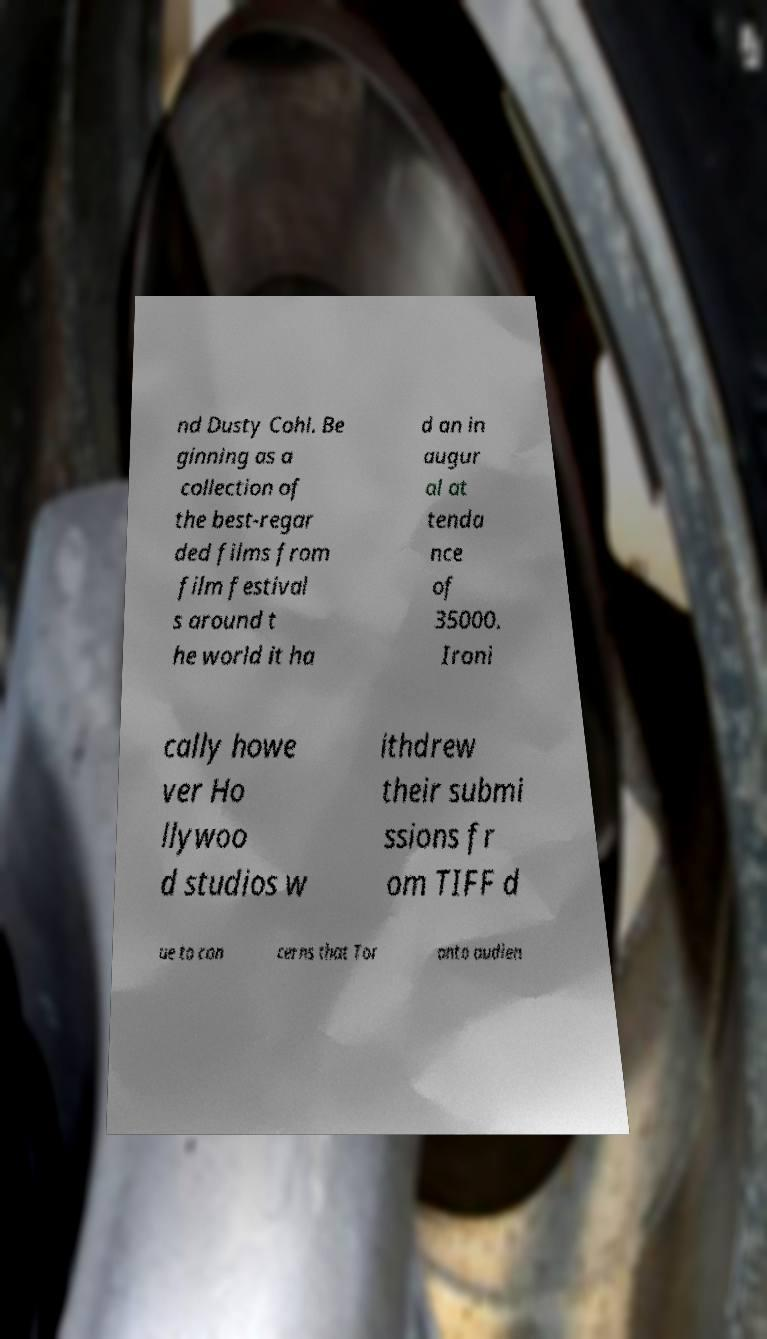There's text embedded in this image that I need extracted. Can you transcribe it verbatim? nd Dusty Cohl. Be ginning as a collection of the best-regar ded films from film festival s around t he world it ha d an in augur al at tenda nce of 35000. Ironi cally howe ver Ho llywoo d studios w ithdrew their submi ssions fr om TIFF d ue to con cerns that Tor onto audien 